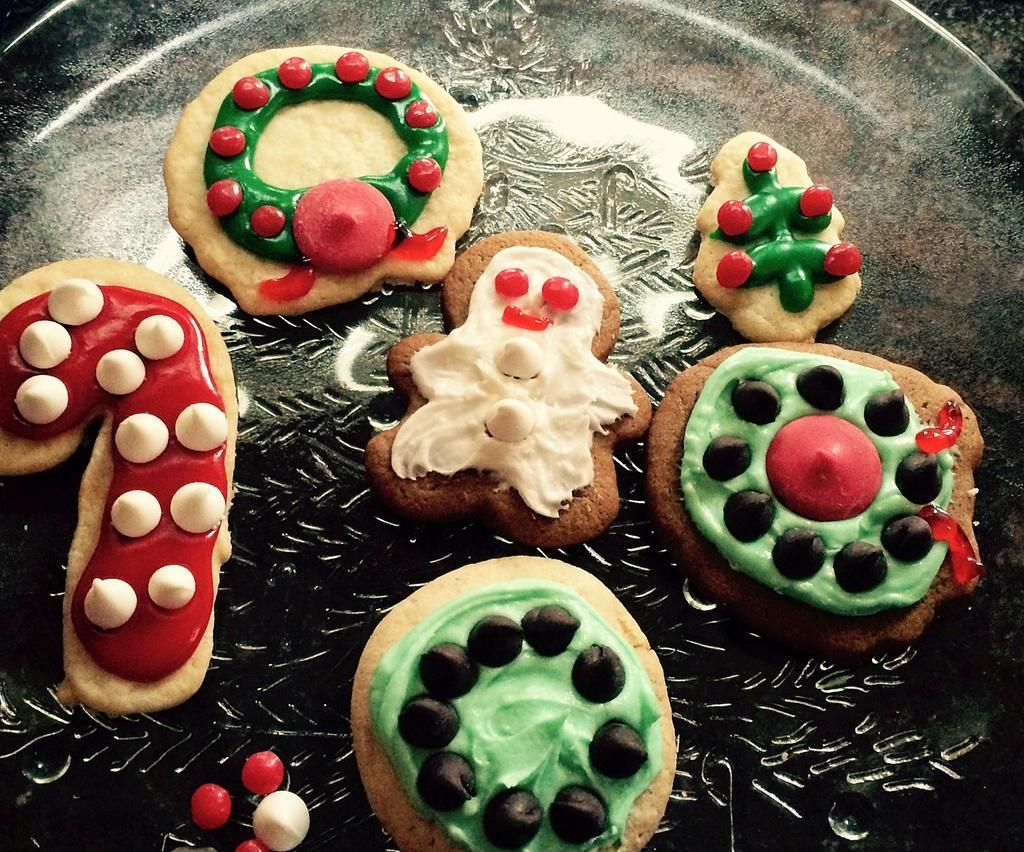How would you summarize this image in a sentence or two? In this image we can see cookies on the surface. 